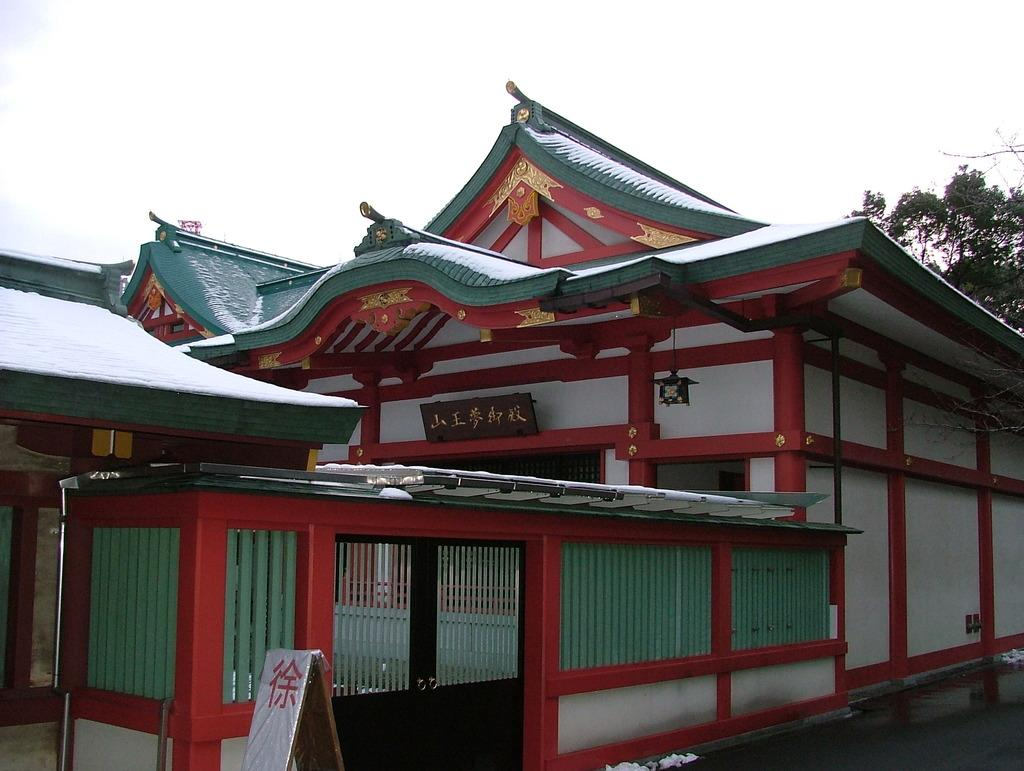What type of structure is visible in the image? There is a building in the image. What can be seen on the right side of the image? There is a tree on the right side of the image. What is visible at the top of the image? The sky is visible at the top of the image. Where is the entrance to the building located in the image? There is a door at the bottom of the image. What type of net is used to catch the hall in the image? There is no net or hall present in the image. 